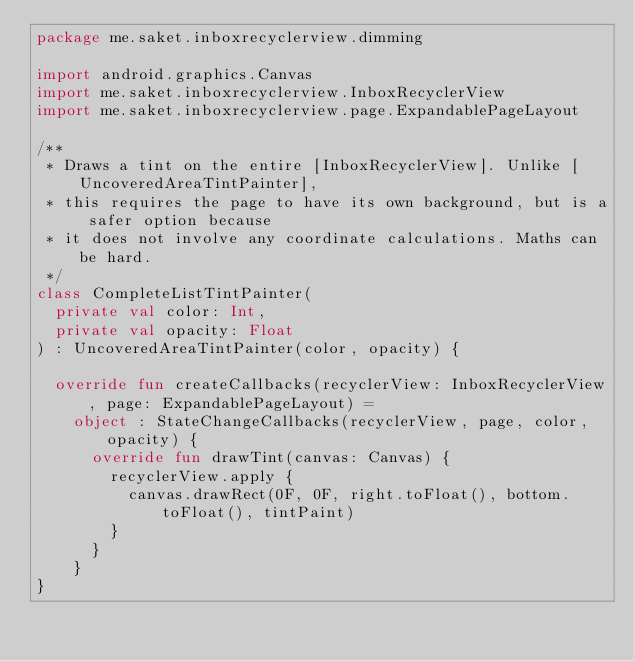Convert code to text. <code><loc_0><loc_0><loc_500><loc_500><_Kotlin_>package me.saket.inboxrecyclerview.dimming

import android.graphics.Canvas
import me.saket.inboxrecyclerview.InboxRecyclerView
import me.saket.inboxrecyclerview.page.ExpandablePageLayout

/**
 * Draws a tint on the entire [InboxRecyclerView]. Unlike [UncoveredAreaTintPainter],
 * this requires the page to have its own background, but is a safer option because
 * it does not involve any coordinate calculations. Maths can be hard.
 */
class CompleteListTintPainter(
  private val color: Int,
  private val opacity: Float
) : UncoveredAreaTintPainter(color, opacity) {

  override fun createCallbacks(recyclerView: InboxRecyclerView, page: ExpandablePageLayout) =
    object : StateChangeCallbacks(recyclerView, page, color, opacity) {
      override fun drawTint(canvas: Canvas) {
        recyclerView.apply {
          canvas.drawRect(0F, 0F, right.toFloat(), bottom.toFloat(), tintPaint)
        }
      }
    }
}
</code> 